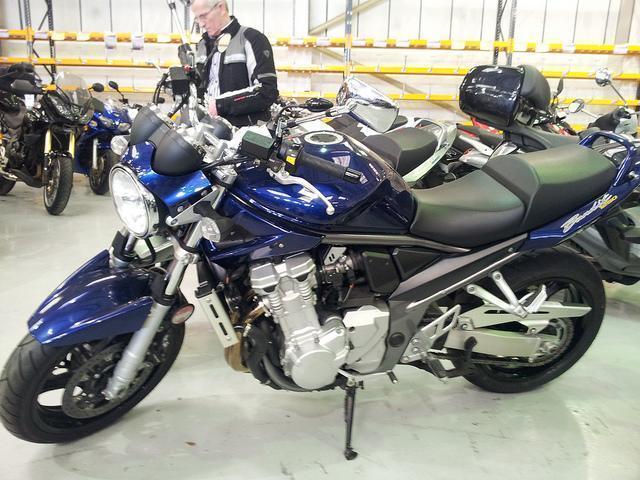What is he doing?
Answer the question by selecting the correct answer among the 4 following choices.
Options: Stealing motorcycles, riding motorcycle, selling motorcycles, viewing motorcycles. Viewing motorcycles. 